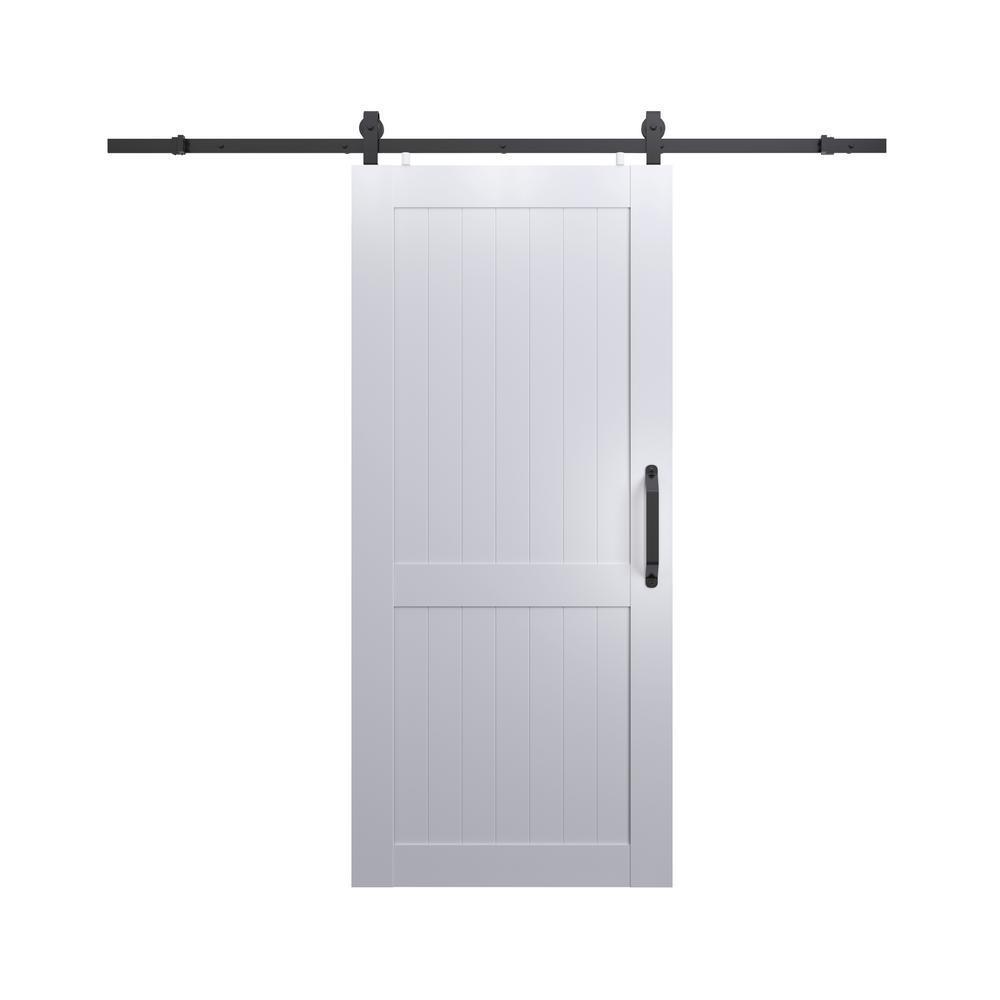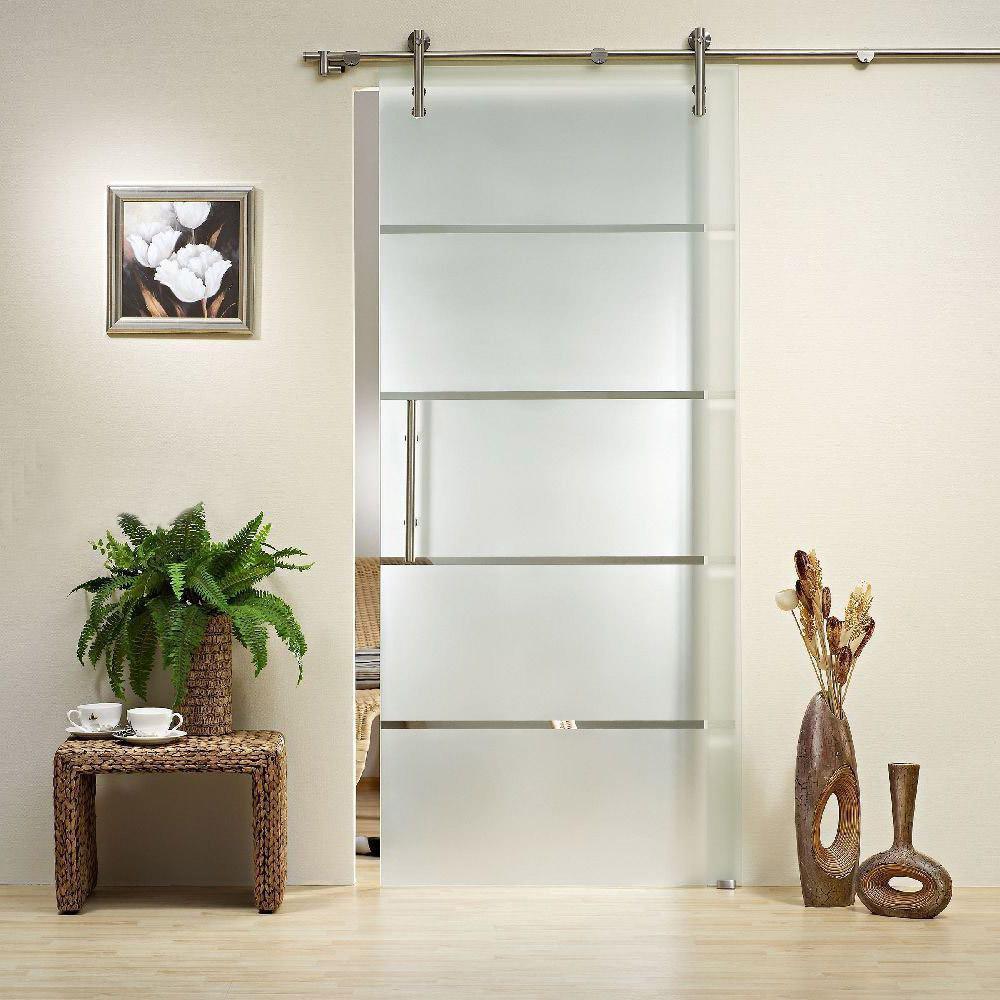The first image is the image on the left, the second image is the image on the right. For the images displayed, is the sentence "The left and right image contains the same number of hanging doors with at least one white wooden door." factually correct? Answer yes or no. Yes. The first image is the image on the left, the second image is the image on the right. Assess this claim about the two images: "There are multiple doors in one image.". Correct or not? Answer yes or no. No. 